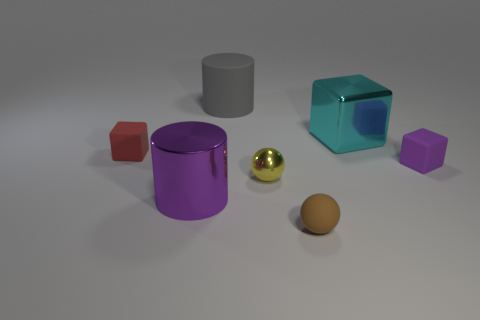Do the shiny thing that is on the right side of the yellow object and the small thing to the right of the tiny brown ball have the same shape?
Offer a very short reply. Yes. What number of objects are either cyan shiny things or tiny red rubber blocks?
Make the answer very short. 2. There is a cyan metal thing that is the same shape as the tiny red matte thing; what is its size?
Make the answer very short. Large. Are there more blocks that are to the right of the brown thing than red matte things?
Provide a short and direct response. Yes. Are the small brown object and the cyan block made of the same material?
Give a very brief answer. No. What number of objects are purple things that are left of the brown rubber object or matte objects that are behind the tiny brown object?
Ensure brevity in your answer.  4. What color is the other metallic thing that is the same shape as the red thing?
Provide a short and direct response. Cyan. What number of small balls have the same color as the big matte cylinder?
Offer a very short reply. 0. Is the metallic ball the same color as the big rubber cylinder?
Your answer should be compact. No. How many objects are either tiny blocks to the left of the large cyan object or small red shiny cylinders?
Your answer should be compact. 1. 